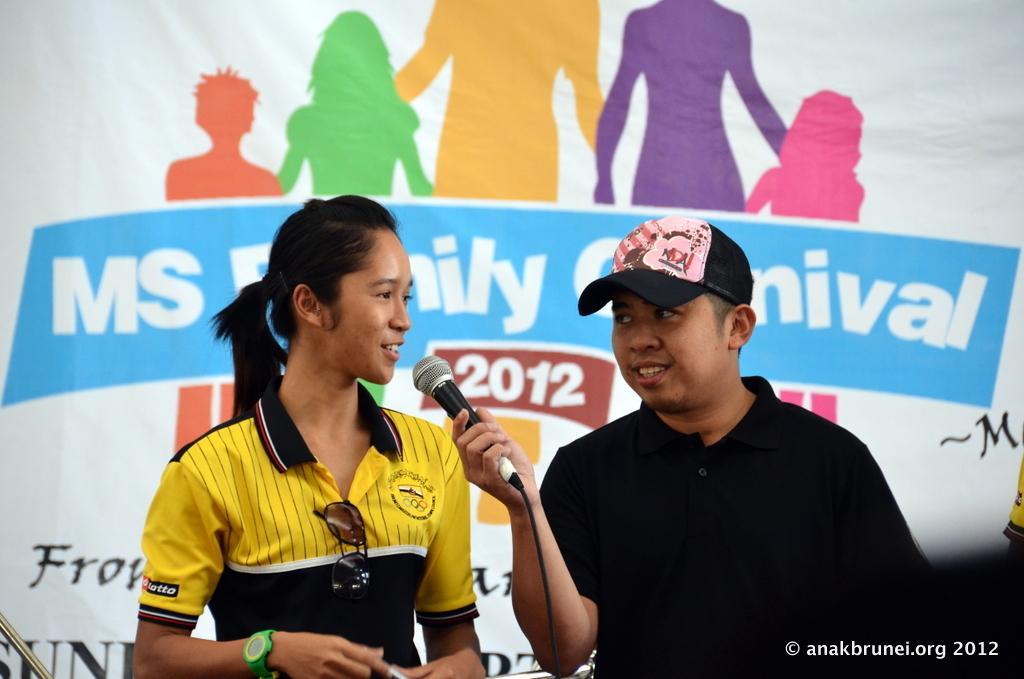Describe this image in one or two sentences. On the right side of the image we can see a person holding a mike towards a girl. On the left side of the image we can see a person speaking to the mic. In the background there is a poster. 